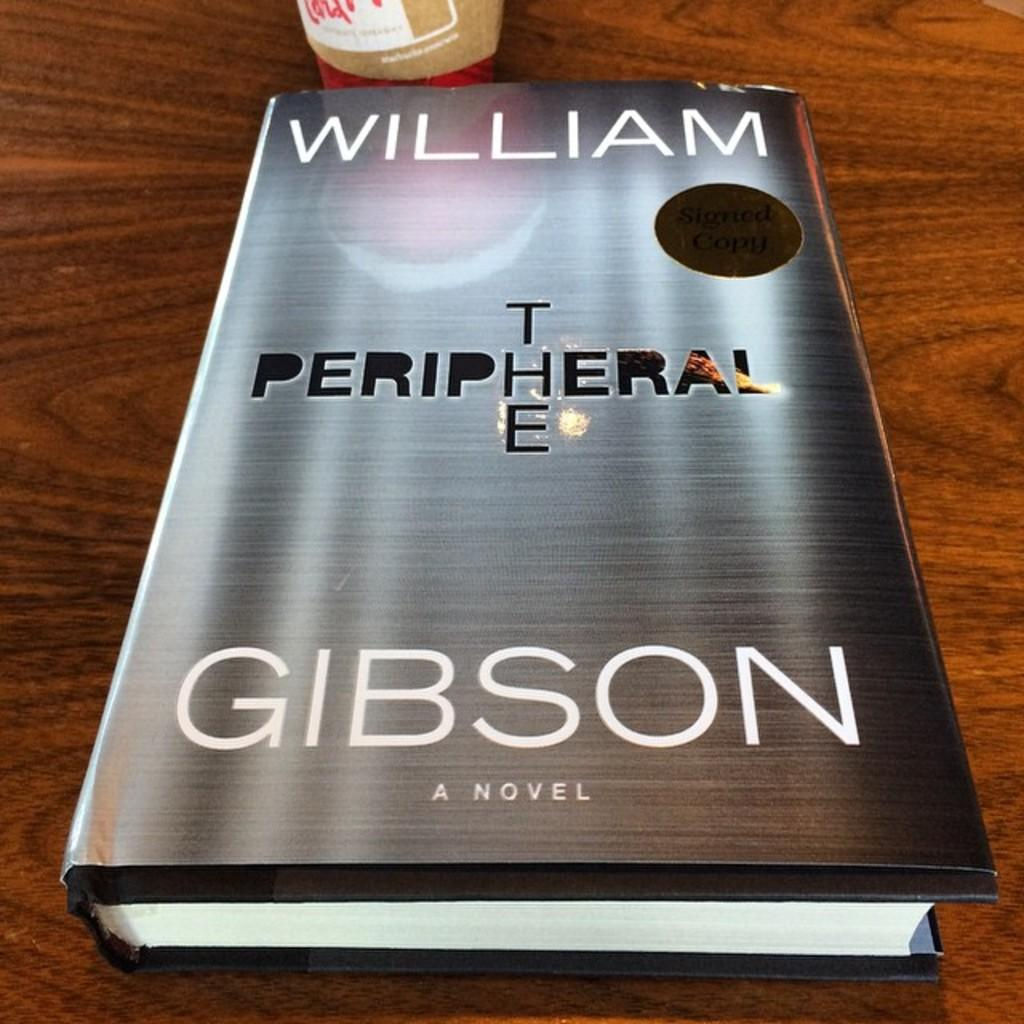<image>
Render a clear and concise summary of the photo. The book on the table is written by William Gibson. 